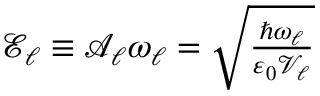Convert formula to latex. <formula><loc_0><loc_0><loc_500><loc_500>\begin{array} { r } { \mathcal { E } _ { \ell } \equiv \mathcal { A } _ { \ell } \omega _ { \ell } = \sqrt { \frac { \hbar { \omega } _ { \ell } } { \varepsilon _ { 0 } \mathcal { V } _ { \ell } } } } \end{array}</formula> 